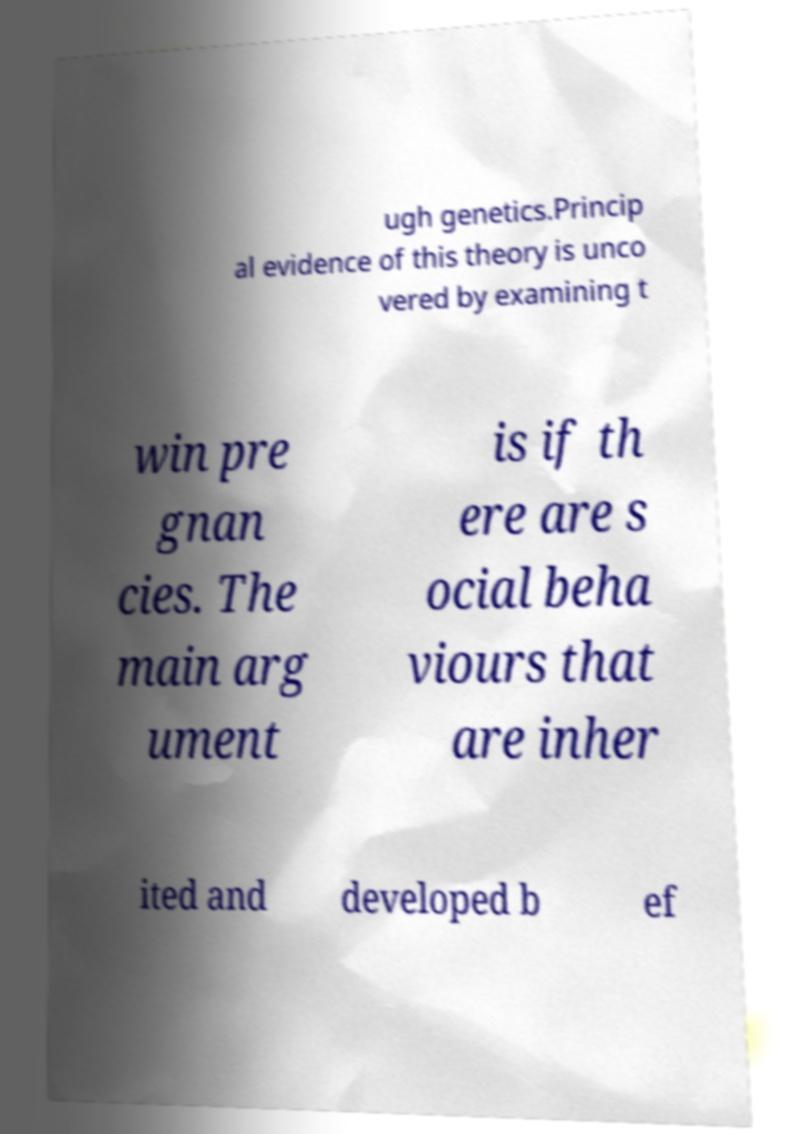What messages or text are displayed in this image? I need them in a readable, typed format. ugh genetics.Princip al evidence of this theory is unco vered by examining t win pre gnan cies. The main arg ument is if th ere are s ocial beha viours that are inher ited and developed b ef 